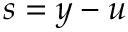<formula> <loc_0><loc_0><loc_500><loc_500>s = y - u</formula> 